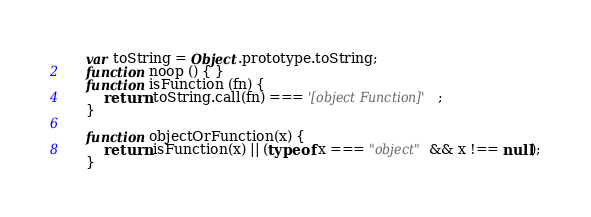<code> <loc_0><loc_0><loc_500><loc_500><_JavaScript_>    var toString = Object.prototype.toString;
    function noop () { }
    function isFunction (fn) {
        return toString.call(fn) === '[object Function]';
    }

    function objectOrFunction(x) {
        return isFunction(x) || (typeof x === "object" && x !== null);
    }
</code> 